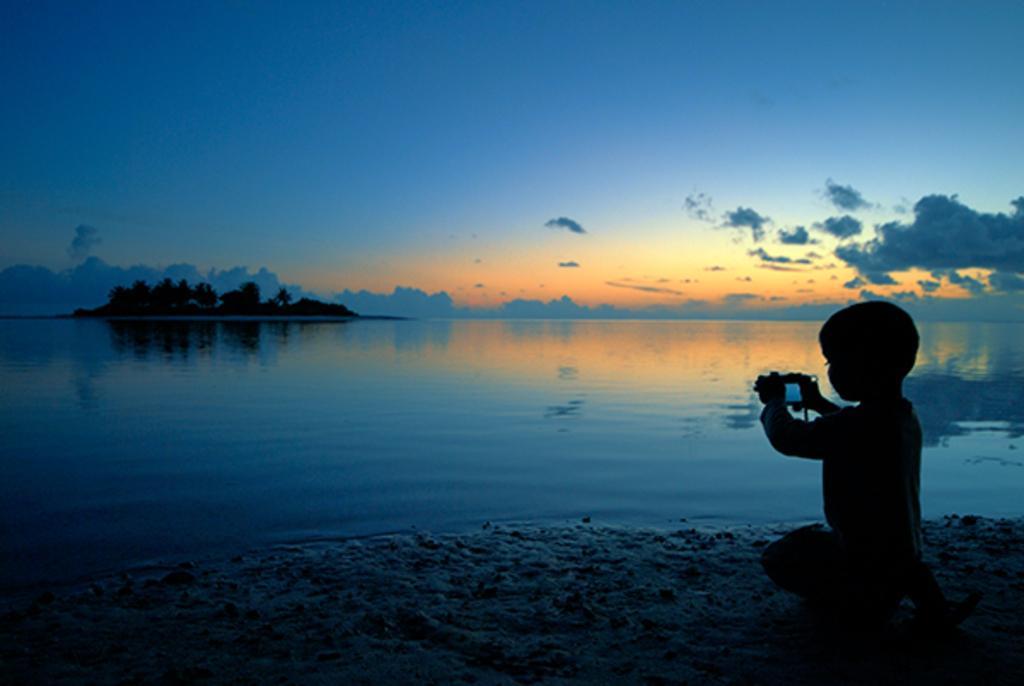How would you summarize this image in a sentence or two? In this image we can see a kid taking a picture using a cell phone, there are trees, also we can see the river and the sky. 